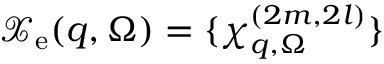Convert formula to latex. <formula><loc_0><loc_0><loc_500><loc_500>\mathcal { X } _ { e } ( q , \Omega ) = \{ \chi _ { q , \Omega } ^ { ( 2 m , 2 l ) } \}</formula> 